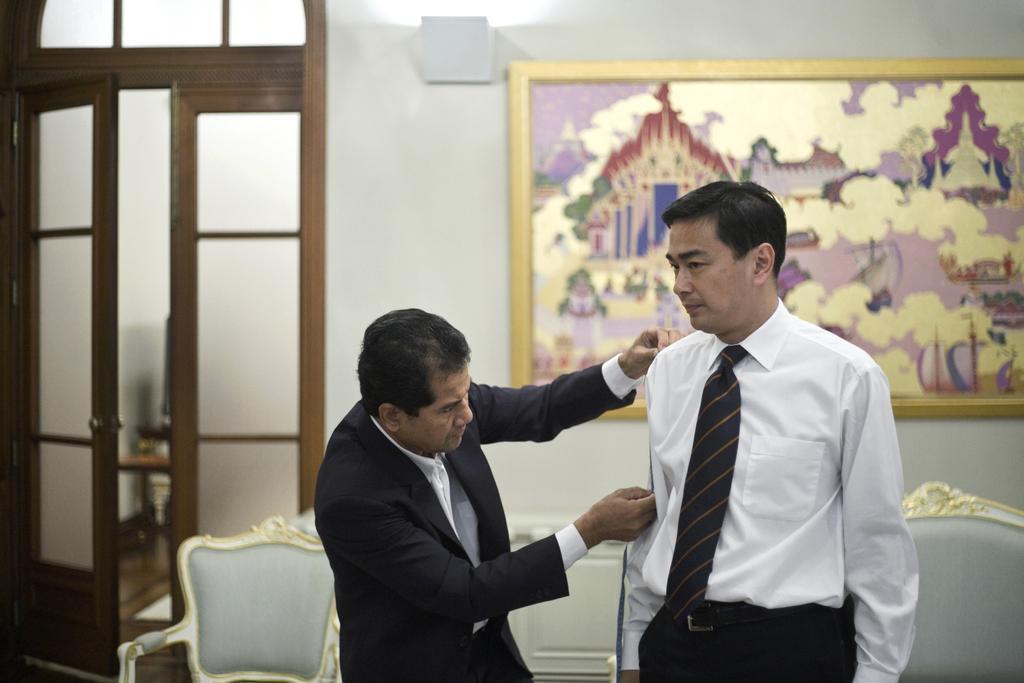Please provide a concise description of this image. On the right there is a man standing and on the left there is a man measuring the right side person body. In the background there are chairs,doors and a frame on the wall. 